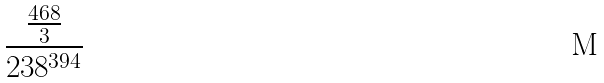<formula> <loc_0><loc_0><loc_500><loc_500>\frac { \frac { 4 6 8 } { 3 } } { 2 3 8 ^ { 3 9 4 } }</formula> 